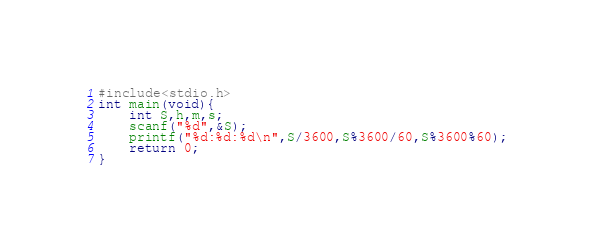<code> <loc_0><loc_0><loc_500><loc_500><_C_>#include<stdio.h>
int main(void){
    int S,h,m,s;
    scanf("%d",&S);
    printf("%d:%d:%d\n",S/3600,S%3600/60,S%3600%60);
    return 0;
}
</code> 